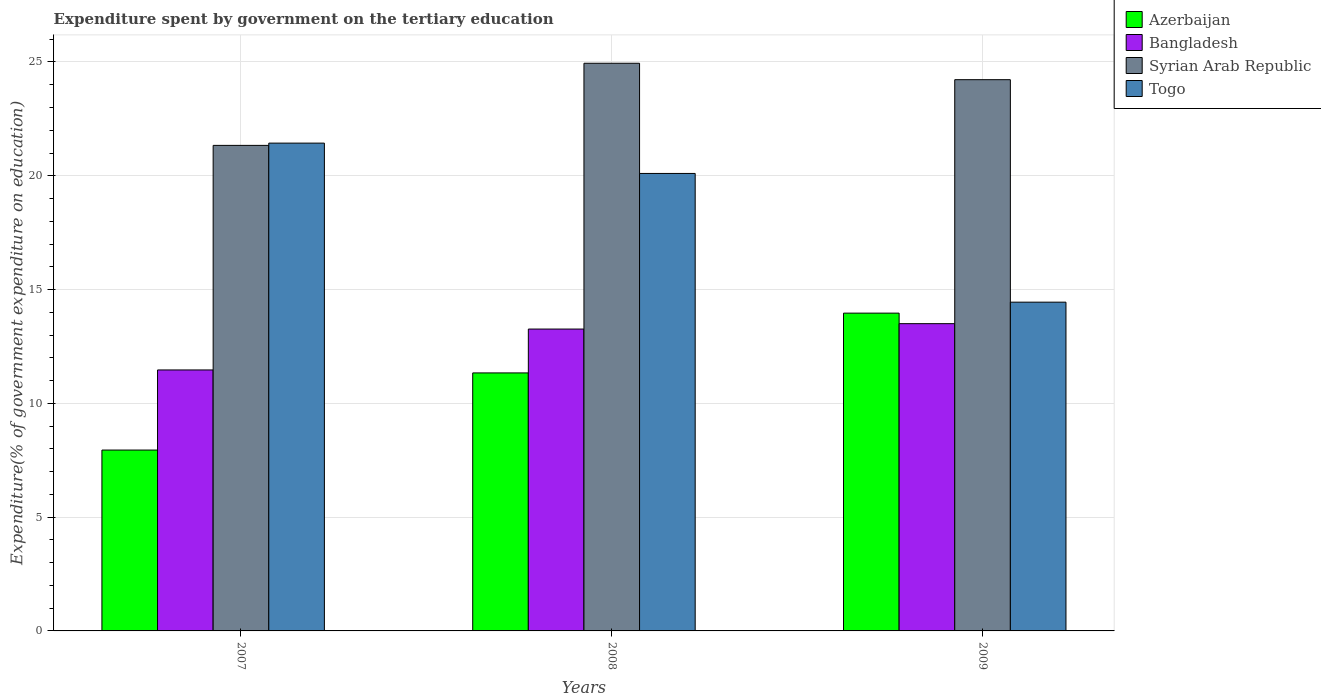Are the number of bars per tick equal to the number of legend labels?
Make the answer very short. Yes. Are the number of bars on each tick of the X-axis equal?
Ensure brevity in your answer.  Yes. How many bars are there on the 1st tick from the left?
Provide a short and direct response. 4. What is the label of the 2nd group of bars from the left?
Provide a succinct answer. 2008. What is the expenditure spent by government on the tertiary education in Bangladesh in 2008?
Offer a terse response. 13.26. Across all years, what is the maximum expenditure spent by government on the tertiary education in Bangladesh?
Offer a terse response. 13.5. Across all years, what is the minimum expenditure spent by government on the tertiary education in Syrian Arab Republic?
Give a very brief answer. 21.34. In which year was the expenditure spent by government on the tertiary education in Bangladesh minimum?
Offer a terse response. 2007. What is the total expenditure spent by government on the tertiary education in Azerbaijan in the graph?
Your answer should be very brief. 33.25. What is the difference between the expenditure spent by government on the tertiary education in Bangladesh in 2007 and that in 2009?
Make the answer very short. -2.03. What is the difference between the expenditure spent by government on the tertiary education in Syrian Arab Republic in 2007 and the expenditure spent by government on the tertiary education in Bangladesh in 2009?
Offer a terse response. 7.83. What is the average expenditure spent by government on the tertiary education in Azerbaijan per year?
Offer a terse response. 11.08. In the year 2007, what is the difference between the expenditure spent by government on the tertiary education in Azerbaijan and expenditure spent by government on the tertiary education in Togo?
Your answer should be compact. -13.49. In how many years, is the expenditure spent by government on the tertiary education in Togo greater than 24 %?
Ensure brevity in your answer.  0. What is the ratio of the expenditure spent by government on the tertiary education in Togo in 2008 to that in 2009?
Ensure brevity in your answer.  1.39. Is the difference between the expenditure spent by government on the tertiary education in Azerbaijan in 2008 and 2009 greater than the difference between the expenditure spent by government on the tertiary education in Togo in 2008 and 2009?
Keep it short and to the point. No. What is the difference between the highest and the second highest expenditure spent by government on the tertiary education in Bangladesh?
Offer a terse response. 0.24. What is the difference between the highest and the lowest expenditure spent by government on the tertiary education in Bangladesh?
Offer a very short reply. 2.03. In how many years, is the expenditure spent by government on the tertiary education in Togo greater than the average expenditure spent by government on the tertiary education in Togo taken over all years?
Give a very brief answer. 2. Is it the case that in every year, the sum of the expenditure spent by government on the tertiary education in Syrian Arab Republic and expenditure spent by government on the tertiary education in Azerbaijan is greater than the sum of expenditure spent by government on the tertiary education in Togo and expenditure spent by government on the tertiary education in Bangladesh?
Your answer should be compact. No. What does the 2nd bar from the left in 2007 represents?
Your answer should be compact. Bangladesh. What does the 4th bar from the right in 2007 represents?
Give a very brief answer. Azerbaijan. Is it the case that in every year, the sum of the expenditure spent by government on the tertiary education in Bangladesh and expenditure spent by government on the tertiary education in Togo is greater than the expenditure spent by government on the tertiary education in Azerbaijan?
Your response must be concise. Yes. How many years are there in the graph?
Provide a succinct answer. 3. What is the difference between two consecutive major ticks on the Y-axis?
Your answer should be very brief. 5. Are the values on the major ticks of Y-axis written in scientific E-notation?
Provide a short and direct response. No. How many legend labels are there?
Keep it short and to the point. 4. How are the legend labels stacked?
Offer a very short reply. Vertical. What is the title of the graph?
Ensure brevity in your answer.  Expenditure spent by government on the tertiary education. What is the label or title of the Y-axis?
Your response must be concise. Expenditure(% of government expenditure on education). What is the Expenditure(% of government expenditure on education) of Azerbaijan in 2007?
Provide a short and direct response. 7.95. What is the Expenditure(% of government expenditure on education) in Bangladesh in 2007?
Your answer should be compact. 11.47. What is the Expenditure(% of government expenditure on education) of Syrian Arab Republic in 2007?
Your answer should be very brief. 21.34. What is the Expenditure(% of government expenditure on education) in Togo in 2007?
Your answer should be very brief. 21.43. What is the Expenditure(% of government expenditure on education) in Azerbaijan in 2008?
Your answer should be very brief. 11.34. What is the Expenditure(% of government expenditure on education) in Bangladesh in 2008?
Offer a very short reply. 13.26. What is the Expenditure(% of government expenditure on education) of Syrian Arab Republic in 2008?
Keep it short and to the point. 24.94. What is the Expenditure(% of government expenditure on education) in Togo in 2008?
Offer a very short reply. 20.1. What is the Expenditure(% of government expenditure on education) in Azerbaijan in 2009?
Provide a short and direct response. 13.96. What is the Expenditure(% of government expenditure on education) in Bangladesh in 2009?
Give a very brief answer. 13.5. What is the Expenditure(% of government expenditure on education) in Syrian Arab Republic in 2009?
Provide a succinct answer. 24.22. What is the Expenditure(% of government expenditure on education) in Togo in 2009?
Offer a terse response. 14.45. Across all years, what is the maximum Expenditure(% of government expenditure on education) of Azerbaijan?
Give a very brief answer. 13.96. Across all years, what is the maximum Expenditure(% of government expenditure on education) in Bangladesh?
Your answer should be compact. 13.5. Across all years, what is the maximum Expenditure(% of government expenditure on education) in Syrian Arab Republic?
Ensure brevity in your answer.  24.94. Across all years, what is the maximum Expenditure(% of government expenditure on education) of Togo?
Your answer should be very brief. 21.43. Across all years, what is the minimum Expenditure(% of government expenditure on education) of Azerbaijan?
Provide a succinct answer. 7.95. Across all years, what is the minimum Expenditure(% of government expenditure on education) in Bangladesh?
Ensure brevity in your answer.  11.47. Across all years, what is the minimum Expenditure(% of government expenditure on education) of Syrian Arab Republic?
Give a very brief answer. 21.34. Across all years, what is the minimum Expenditure(% of government expenditure on education) in Togo?
Your answer should be compact. 14.45. What is the total Expenditure(% of government expenditure on education) in Azerbaijan in the graph?
Offer a very short reply. 33.25. What is the total Expenditure(% of government expenditure on education) of Bangladesh in the graph?
Your answer should be compact. 38.23. What is the total Expenditure(% of government expenditure on education) of Syrian Arab Republic in the graph?
Provide a succinct answer. 70.5. What is the total Expenditure(% of government expenditure on education) in Togo in the graph?
Ensure brevity in your answer.  55.98. What is the difference between the Expenditure(% of government expenditure on education) of Azerbaijan in 2007 and that in 2008?
Make the answer very short. -3.39. What is the difference between the Expenditure(% of government expenditure on education) of Bangladesh in 2007 and that in 2008?
Give a very brief answer. -1.8. What is the difference between the Expenditure(% of government expenditure on education) of Syrian Arab Republic in 2007 and that in 2008?
Provide a short and direct response. -3.61. What is the difference between the Expenditure(% of government expenditure on education) in Togo in 2007 and that in 2008?
Give a very brief answer. 1.33. What is the difference between the Expenditure(% of government expenditure on education) in Azerbaijan in 2007 and that in 2009?
Provide a succinct answer. -6.02. What is the difference between the Expenditure(% of government expenditure on education) in Bangladesh in 2007 and that in 2009?
Give a very brief answer. -2.03. What is the difference between the Expenditure(% of government expenditure on education) in Syrian Arab Republic in 2007 and that in 2009?
Give a very brief answer. -2.89. What is the difference between the Expenditure(% of government expenditure on education) of Togo in 2007 and that in 2009?
Provide a succinct answer. 6.99. What is the difference between the Expenditure(% of government expenditure on education) of Azerbaijan in 2008 and that in 2009?
Ensure brevity in your answer.  -2.63. What is the difference between the Expenditure(% of government expenditure on education) of Bangladesh in 2008 and that in 2009?
Offer a terse response. -0.24. What is the difference between the Expenditure(% of government expenditure on education) in Syrian Arab Republic in 2008 and that in 2009?
Give a very brief answer. 0.72. What is the difference between the Expenditure(% of government expenditure on education) of Togo in 2008 and that in 2009?
Give a very brief answer. 5.66. What is the difference between the Expenditure(% of government expenditure on education) in Azerbaijan in 2007 and the Expenditure(% of government expenditure on education) in Bangladesh in 2008?
Offer a very short reply. -5.32. What is the difference between the Expenditure(% of government expenditure on education) of Azerbaijan in 2007 and the Expenditure(% of government expenditure on education) of Syrian Arab Republic in 2008?
Provide a short and direct response. -17. What is the difference between the Expenditure(% of government expenditure on education) in Azerbaijan in 2007 and the Expenditure(% of government expenditure on education) in Togo in 2008?
Provide a succinct answer. -12.15. What is the difference between the Expenditure(% of government expenditure on education) in Bangladesh in 2007 and the Expenditure(% of government expenditure on education) in Syrian Arab Republic in 2008?
Provide a succinct answer. -13.48. What is the difference between the Expenditure(% of government expenditure on education) in Bangladesh in 2007 and the Expenditure(% of government expenditure on education) in Togo in 2008?
Provide a short and direct response. -8.64. What is the difference between the Expenditure(% of government expenditure on education) of Syrian Arab Republic in 2007 and the Expenditure(% of government expenditure on education) of Togo in 2008?
Provide a short and direct response. 1.23. What is the difference between the Expenditure(% of government expenditure on education) in Azerbaijan in 2007 and the Expenditure(% of government expenditure on education) in Bangladesh in 2009?
Provide a succinct answer. -5.55. What is the difference between the Expenditure(% of government expenditure on education) in Azerbaijan in 2007 and the Expenditure(% of government expenditure on education) in Syrian Arab Republic in 2009?
Provide a succinct answer. -16.27. What is the difference between the Expenditure(% of government expenditure on education) of Azerbaijan in 2007 and the Expenditure(% of government expenditure on education) of Togo in 2009?
Keep it short and to the point. -6.5. What is the difference between the Expenditure(% of government expenditure on education) in Bangladesh in 2007 and the Expenditure(% of government expenditure on education) in Syrian Arab Republic in 2009?
Keep it short and to the point. -12.76. What is the difference between the Expenditure(% of government expenditure on education) of Bangladesh in 2007 and the Expenditure(% of government expenditure on education) of Togo in 2009?
Your answer should be very brief. -2.98. What is the difference between the Expenditure(% of government expenditure on education) in Syrian Arab Republic in 2007 and the Expenditure(% of government expenditure on education) in Togo in 2009?
Your answer should be very brief. 6.89. What is the difference between the Expenditure(% of government expenditure on education) of Azerbaijan in 2008 and the Expenditure(% of government expenditure on education) of Bangladesh in 2009?
Offer a terse response. -2.16. What is the difference between the Expenditure(% of government expenditure on education) of Azerbaijan in 2008 and the Expenditure(% of government expenditure on education) of Syrian Arab Republic in 2009?
Offer a terse response. -12.89. What is the difference between the Expenditure(% of government expenditure on education) of Azerbaijan in 2008 and the Expenditure(% of government expenditure on education) of Togo in 2009?
Give a very brief answer. -3.11. What is the difference between the Expenditure(% of government expenditure on education) of Bangladesh in 2008 and the Expenditure(% of government expenditure on education) of Syrian Arab Republic in 2009?
Your response must be concise. -10.96. What is the difference between the Expenditure(% of government expenditure on education) in Bangladesh in 2008 and the Expenditure(% of government expenditure on education) in Togo in 2009?
Offer a terse response. -1.18. What is the difference between the Expenditure(% of government expenditure on education) in Syrian Arab Republic in 2008 and the Expenditure(% of government expenditure on education) in Togo in 2009?
Give a very brief answer. 10.5. What is the average Expenditure(% of government expenditure on education) in Azerbaijan per year?
Your response must be concise. 11.08. What is the average Expenditure(% of government expenditure on education) of Bangladesh per year?
Offer a terse response. 12.74. What is the average Expenditure(% of government expenditure on education) of Syrian Arab Republic per year?
Your answer should be very brief. 23.5. What is the average Expenditure(% of government expenditure on education) of Togo per year?
Provide a succinct answer. 18.66. In the year 2007, what is the difference between the Expenditure(% of government expenditure on education) of Azerbaijan and Expenditure(% of government expenditure on education) of Bangladesh?
Your answer should be compact. -3.52. In the year 2007, what is the difference between the Expenditure(% of government expenditure on education) in Azerbaijan and Expenditure(% of government expenditure on education) in Syrian Arab Republic?
Your response must be concise. -13.39. In the year 2007, what is the difference between the Expenditure(% of government expenditure on education) in Azerbaijan and Expenditure(% of government expenditure on education) in Togo?
Give a very brief answer. -13.49. In the year 2007, what is the difference between the Expenditure(% of government expenditure on education) of Bangladesh and Expenditure(% of government expenditure on education) of Syrian Arab Republic?
Offer a terse response. -9.87. In the year 2007, what is the difference between the Expenditure(% of government expenditure on education) in Bangladesh and Expenditure(% of government expenditure on education) in Togo?
Provide a succinct answer. -9.97. In the year 2007, what is the difference between the Expenditure(% of government expenditure on education) of Syrian Arab Republic and Expenditure(% of government expenditure on education) of Togo?
Give a very brief answer. -0.1. In the year 2008, what is the difference between the Expenditure(% of government expenditure on education) in Azerbaijan and Expenditure(% of government expenditure on education) in Bangladesh?
Ensure brevity in your answer.  -1.93. In the year 2008, what is the difference between the Expenditure(% of government expenditure on education) of Azerbaijan and Expenditure(% of government expenditure on education) of Syrian Arab Republic?
Provide a succinct answer. -13.61. In the year 2008, what is the difference between the Expenditure(% of government expenditure on education) of Azerbaijan and Expenditure(% of government expenditure on education) of Togo?
Provide a succinct answer. -8.77. In the year 2008, what is the difference between the Expenditure(% of government expenditure on education) of Bangladesh and Expenditure(% of government expenditure on education) of Syrian Arab Republic?
Provide a succinct answer. -11.68. In the year 2008, what is the difference between the Expenditure(% of government expenditure on education) in Bangladesh and Expenditure(% of government expenditure on education) in Togo?
Keep it short and to the point. -6.84. In the year 2008, what is the difference between the Expenditure(% of government expenditure on education) of Syrian Arab Republic and Expenditure(% of government expenditure on education) of Togo?
Your response must be concise. 4.84. In the year 2009, what is the difference between the Expenditure(% of government expenditure on education) of Azerbaijan and Expenditure(% of government expenditure on education) of Bangladesh?
Make the answer very short. 0.46. In the year 2009, what is the difference between the Expenditure(% of government expenditure on education) in Azerbaijan and Expenditure(% of government expenditure on education) in Syrian Arab Republic?
Offer a terse response. -10.26. In the year 2009, what is the difference between the Expenditure(% of government expenditure on education) of Azerbaijan and Expenditure(% of government expenditure on education) of Togo?
Provide a succinct answer. -0.48. In the year 2009, what is the difference between the Expenditure(% of government expenditure on education) in Bangladesh and Expenditure(% of government expenditure on education) in Syrian Arab Republic?
Offer a very short reply. -10.72. In the year 2009, what is the difference between the Expenditure(% of government expenditure on education) in Bangladesh and Expenditure(% of government expenditure on education) in Togo?
Your answer should be compact. -0.94. In the year 2009, what is the difference between the Expenditure(% of government expenditure on education) of Syrian Arab Republic and Expenditure(% of government expenditure on education) of Togo?
Your answer should be very brief. 9.78. What is the ratio of the Expenditure(% of government expenditure on education) in Azerbaijan in 2007 to that in 2008?
Offer a very short reply. 0.7. What is the ratio of the Expenditure(% of government expenditure on education) in Bangladesh in 2007 to that in 2008?
Ensure brevity in your answer.  0.86. What is the ratio of the Expenditure(% of government expenditure on education) of Syrian Arab Republic in 2007 to that in 2008?
Your answer should be compact. 0.86. What is the ratio of the Expenditure(% of government expenditure on education) in Togo in 2007 to that in 2008?
Give a very brief answer. 1.07. What is the ratio of the Expenditure(% of government expenditure on education) in Azerbaijan in 2007 to that in 2009?
Your answer should be compact. 0.57. What is the ratio of the Expenditure(% of government expenditure on education) of Bangladesh in 2007 to that in 2009?
Your answer should be very brief. 0.85. What is the ratio of the Expenditure(% of government expenditure on education) in Syrian Arab Republic in 2007 to that in 2009?
Give a very brief answer. 0.88. What is the ratio of the Expenditure(% of government expenditure on education) in Togo in 2007 to that in 2009?
Offer a very short reply. 1.48. What is the ratio of the Expenditure(% of government expenditure on education) of Azerbaijan in 2008 to that in 2009?
Give a very brief answer. 0.81. What is the ratio of the Expenditure(% of government expenditure on education) of Bangladesh in 2008 to that in 2009?
Your answer should be very brief. 0.98. What is the ratio of the Expenditure(% of government expenditure on education) of Syrian Arab Republic in 2008 to that in 2009?
Give a very brief answer. 1.03. What is the ratio of the Expenditure(% of government expenditure on education) in Togo in 2008 to that in 2009?
Your answer should be compact. 1.39. What is the difference between the highest and the second highest Expenditure(% of government expenditure on education) of Azerbaijan?
Ensure brevity in your answer.  2.63. What is the difference between the highest and the second highest Expenditure(% of government expenditure on education) in Bangladesh?
Your response must be concise. 0.24. What is the difference between the highest and the second highest Expenditure(% of government expenditure on education) of Syrian Arab Republic?
Ensure brevity in your answer.  0.72. What is the difference between the highest and the second highest Expenditure(% of government expenditure on education) in Togo?
Ensure brevity in your answer.  1.33. What is the difference between the highest and the lowest Expenditure(% of government expenditure on education) of Azerbaijan?
Your response must be concise. 6.02. What is the difference between the highest and the lowest Expenditure(% of government expenditure on education) of Bangladesh?
Give a very brief answer. 2.03. What is the difference between the highest and the lowest Expenditure(% of government expenditure on education) in Syrian Arab Republic?
Offer a very short reply. 3.61. What is the difference between the highest and the lowest Expenditure(% of government expenditure on education) of Togo?
Your response must be concise. 6.99. 